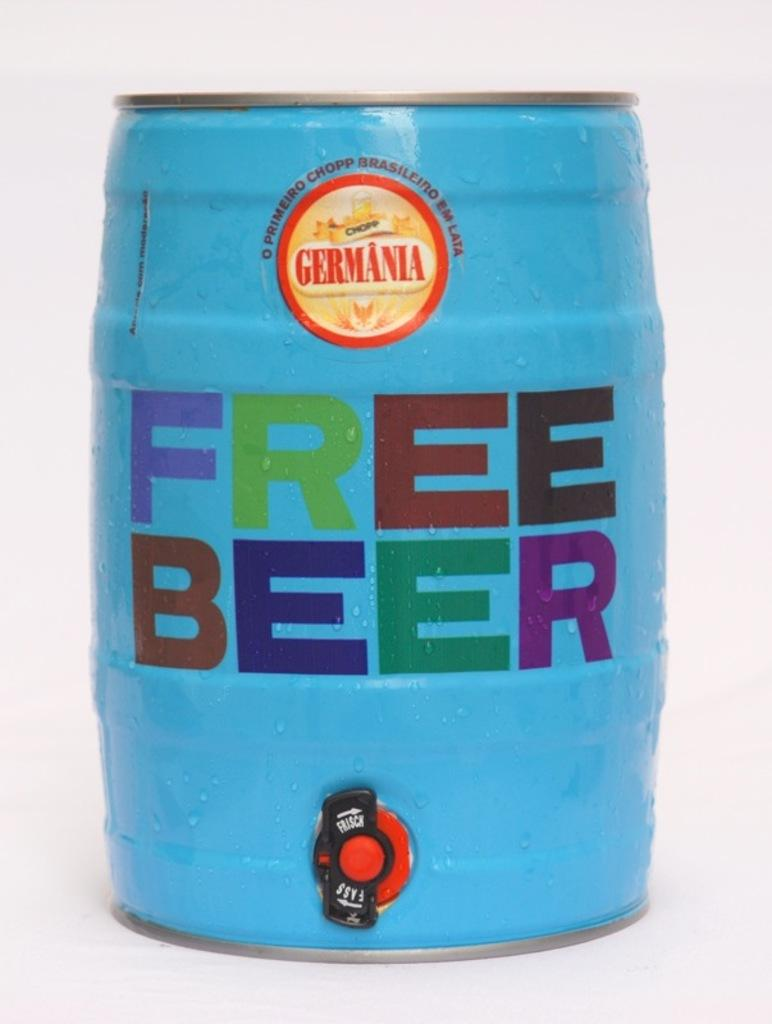<image>
Provide a brief description of the given image. A blue keg is labeled as free beer. 